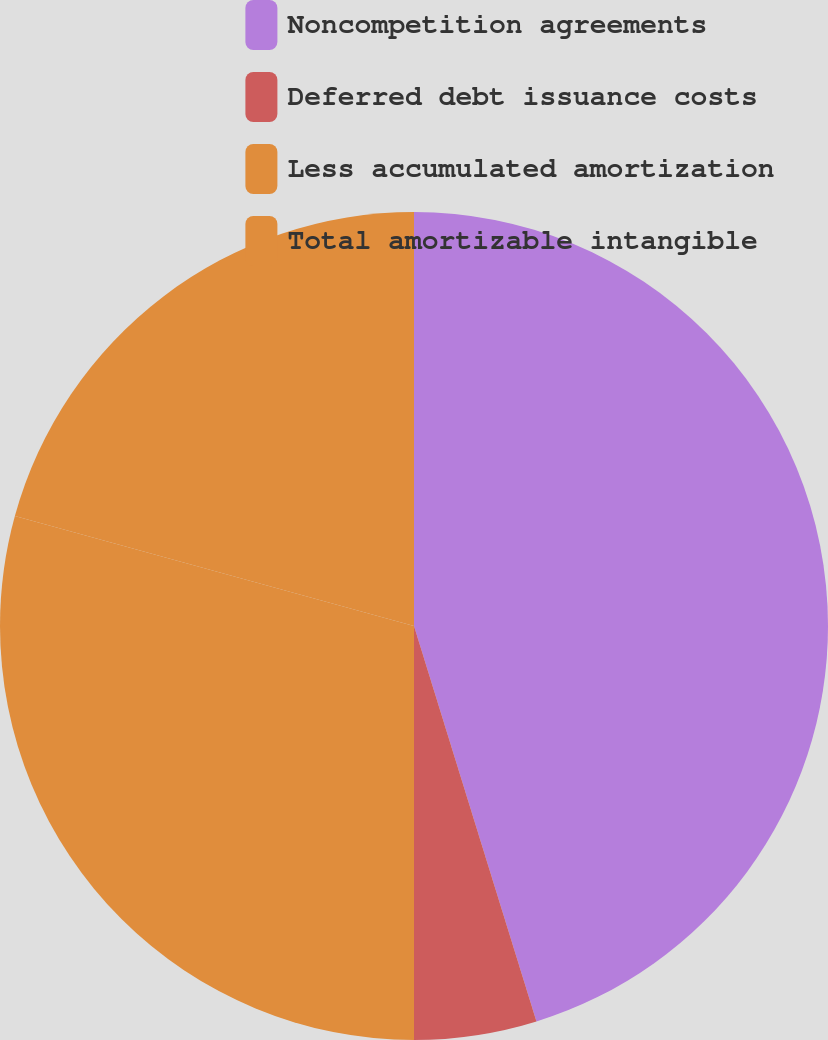Convert chart to OTSL. <chart><loc_0><loc_0><loc_500><loc_500><pie_chart><fcel>Noncompetition agreements<fcel>Deferred debt issuance costs<fcel>Less accumulated amortization<fcel>Total amortizable intangible<nl><fcel>45.22%<fcel>4.78%<fcel>29.28%<fcel>20.72%<nl></chart> 